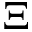Convert formula to latex. <formula><loc_0><loc_0><loc_500><loc_500>\Xi</formula> 